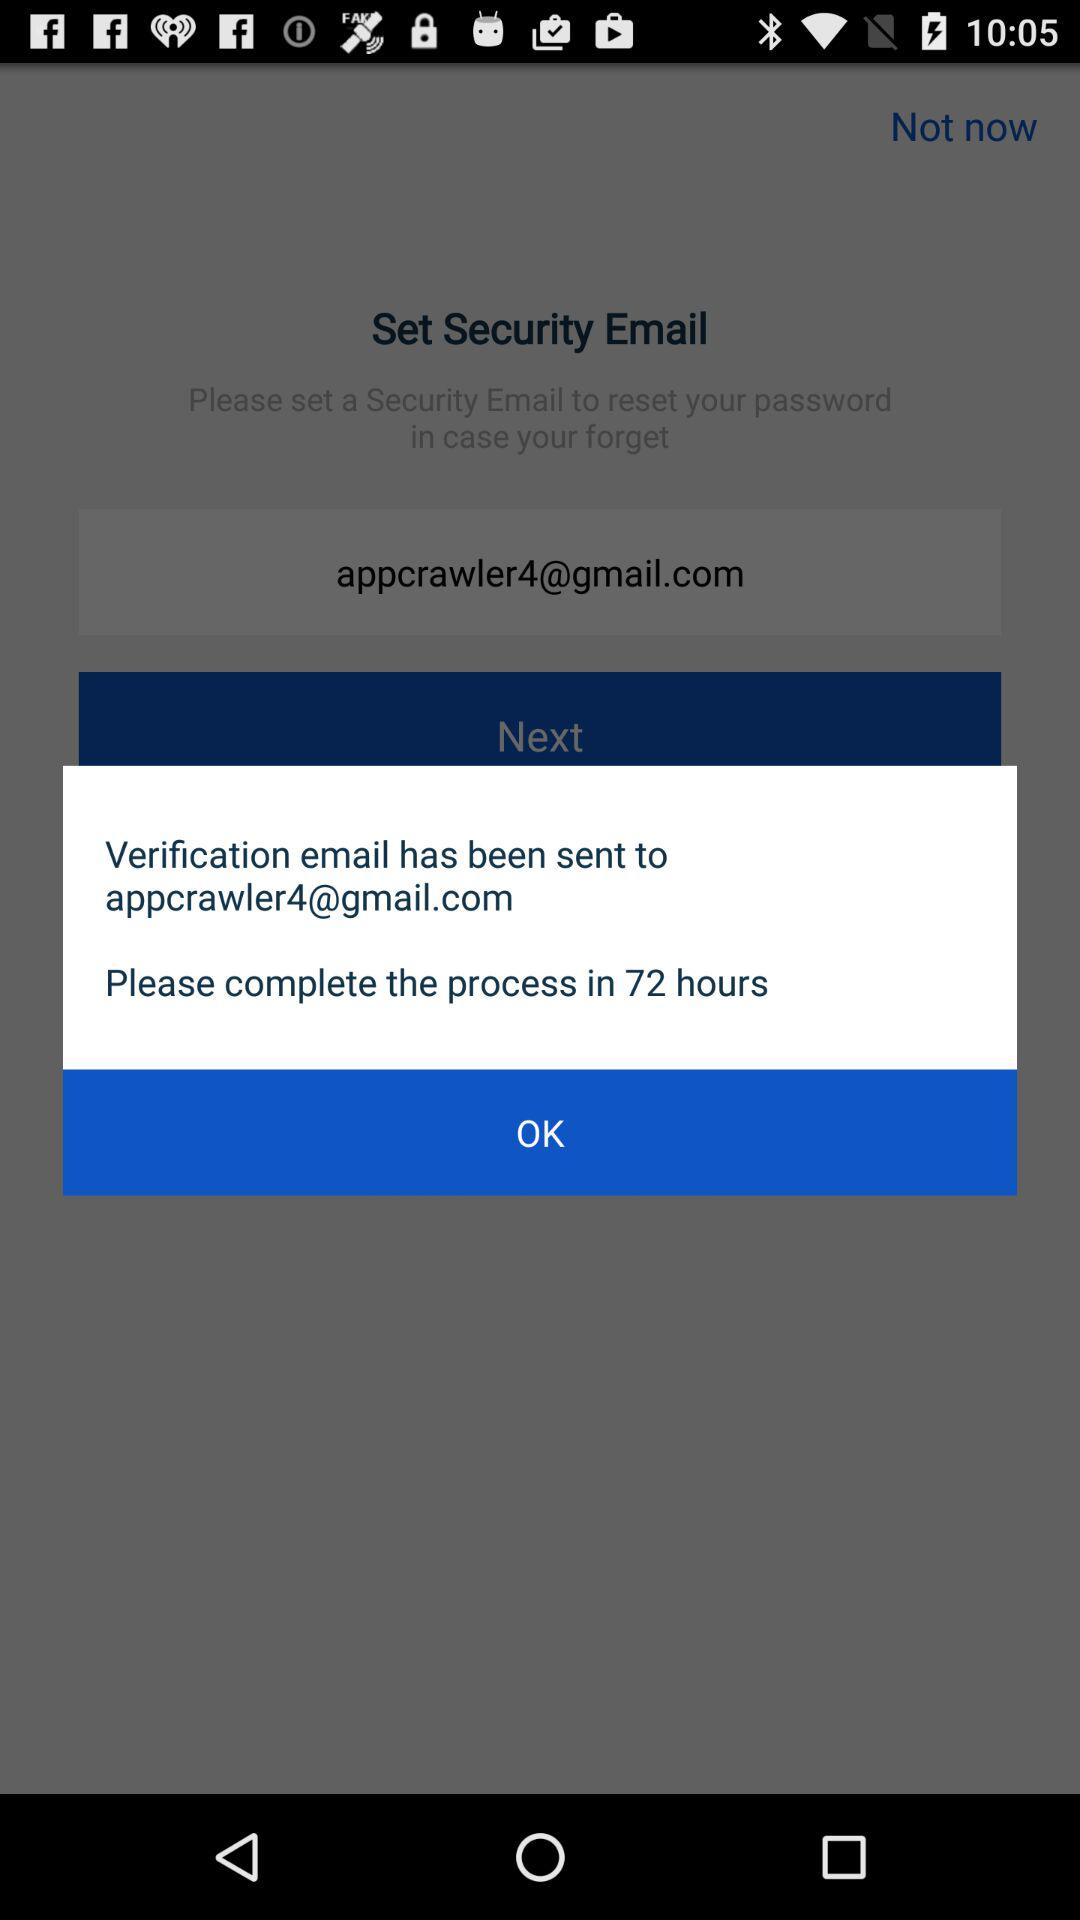What email address has the verification email been sent to? The verification email has been sent to appcrawler4@gmail.com. 